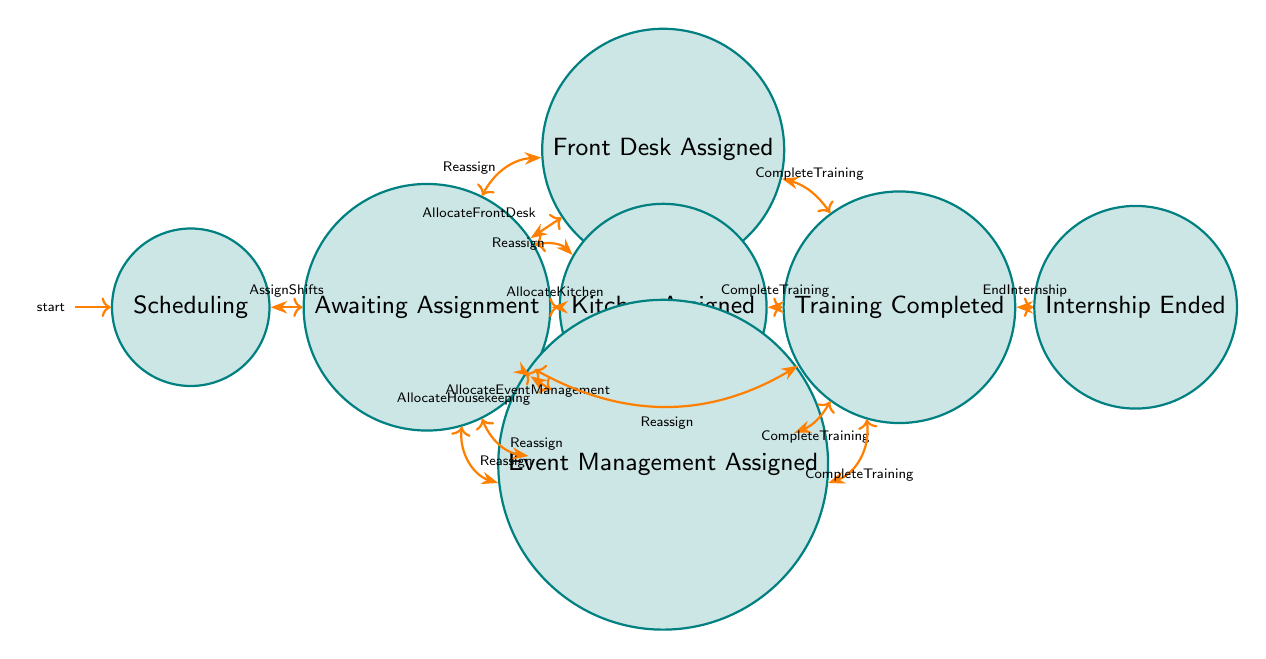What is the initial state of the diagram? The initial state is represented as the starting point in the diagram, labeled as "Scheduling." This can be identified as it is the only state with an incoming arrow but no outgoing transitions leading from another state.
Answer: Scheduling How many states are represented in the diagram? The total number of states can be obtained by counting all the distinct states displayed in the diagram, which are Scheduling, AwaitingAssignment, FrontDeskAssigned, KitchenAssigned, HousekeepingAssigned, EventManagementAssigned, TrainingCompleted, and InternshipEnded. This is a total of eight states.
Answer: 8 What transition occurs after "AwaitingAssignment"? In the "AwaitingAssignment" state, there are multiple options for transitions, but all lead to different assigned states. The transition names indicating possible actions from "AwaitingAssignment" are AllocateFrontDesk, AllocateKitchen, AllocateHousekeeping, and AllocateEventManagement.
Answer: AllocateFrontDesk, AllocateKitchen, AllocateHousekeeping, AllocateEventManagement Which state follows "TrainingCompleted"? After the "TrainingCompleted" state, the next possible transitions are either to "InternshipEnded" or back to "AwaitingAssignment" if a student is reassigned. However, the direct transition to "InternshipEnded" can be directly identified as the endpoint after successfully completing training.
Answer: InternshipEnded What happens if a student is "Reassigned" from the "KitchenAssigned" state? When a student is in the "KitchenAssigned" state and is "Reassigned," the transition leads back to the "AwaitingAssignment" state. This indicates that the process of assigning a new department begins again.
Answer: AwaitingAssignment How many transitions lead to the "AwaitingAssignment" state? To find the number of transitions that lead to the "AwaitingAssignment" state, we look for all arrows pointing toward it. All assigned states (FrontDeskAssigned, KitchenAssigned, HousekeepingAssigned, EventManagementAssigned, and TrainingCompleted) can transition back to "AwaitingAssignment," totaling five transitions.
Answer: 5 What is the relationship between "EventManagementAssigned" and "TrainingCompleted"? The direct relationship is that the "EventManagementAssigned" state has a transition leading to "TrainingCompleted," indicating that upon completing training in the Event Management department, the next state is "TrainingCompleted."
Answer: Transition to TrainingCompleted From which state can the "EndInternship" transition be executed? The "EndInternship" transition occurs from the "TrainingCompleted" state, which signifies that the training phase has reached completion and the internship can now be concluded.
Answer: TrainingCompleted 